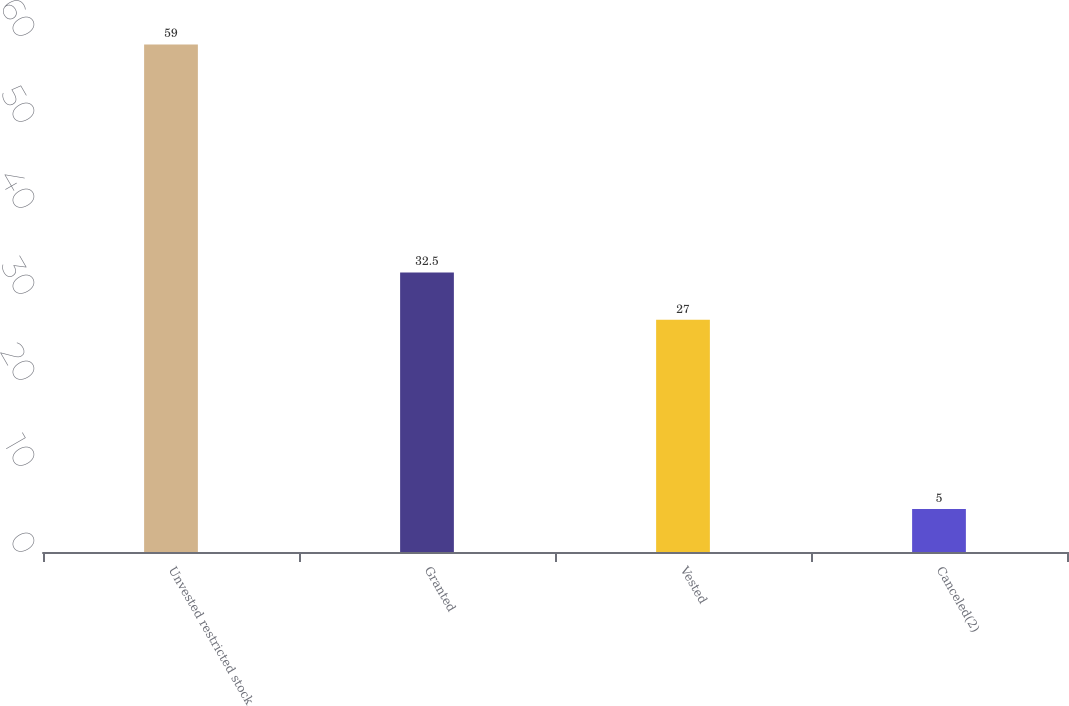Convert chart. <chart><loc_0><loc_0><loc_500><loc_500><bar_chart><fcel>Unvested restricted stock<fcel>Granted<fcel>Vested<fcel>Canceled(2)<nl><fcel>59<fcel>32.5<fcel>27<fcel>5<nl></chart> 